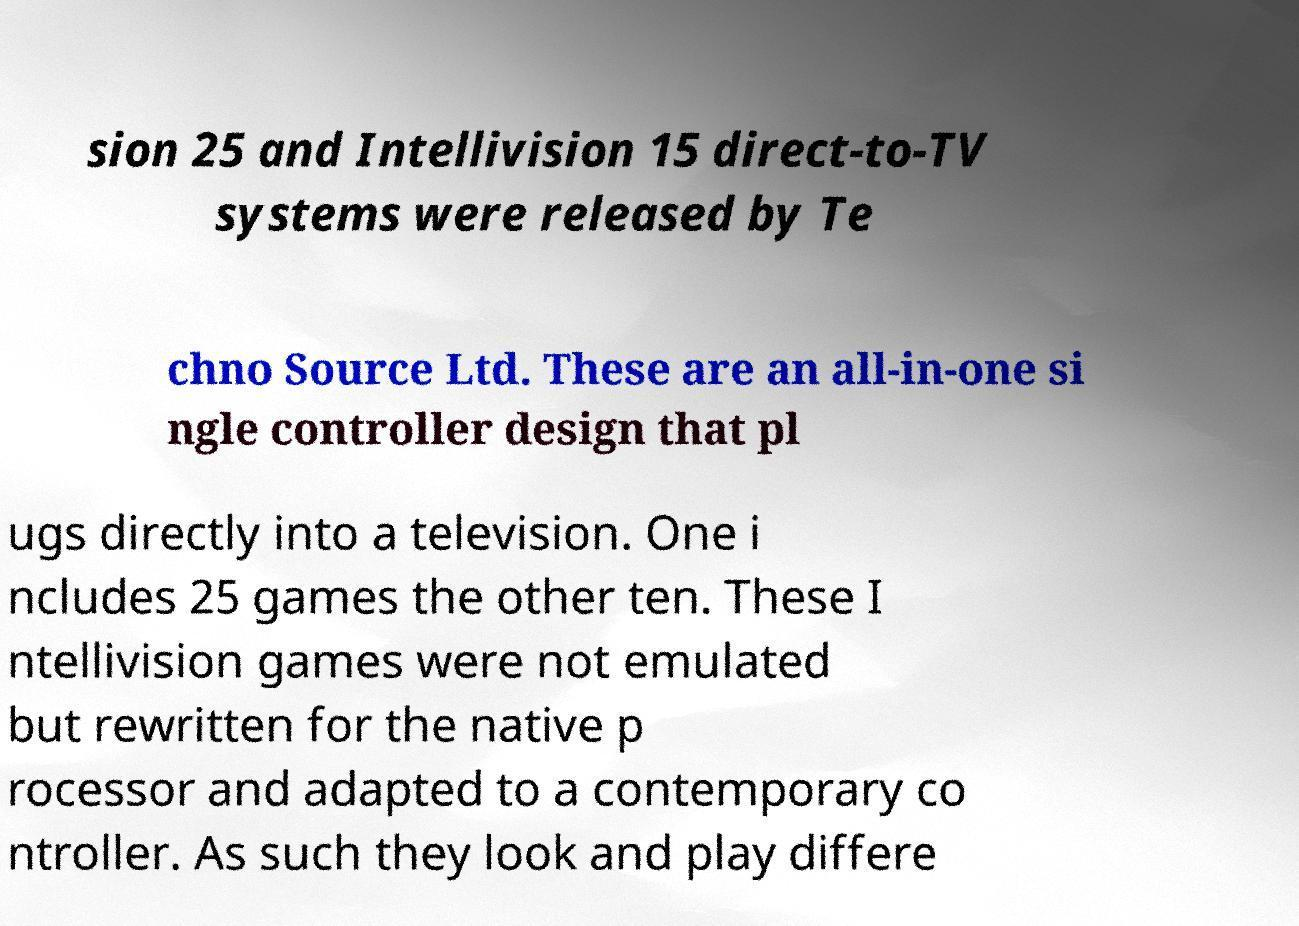Please read and relay the text visible in this image. What does it say? sion 25 and Intellivision 15 direct-to-TV systems were released by Te chno Source Ltd. These are an all-in-one si ngle controller design that pl ugs directly into a television. One i ncludes 25 games the other ten. These I ntellivision games were not emulated but rewritten for the native p rocessor and adapted to a contemporary co ntroller. As such they look and play differe 